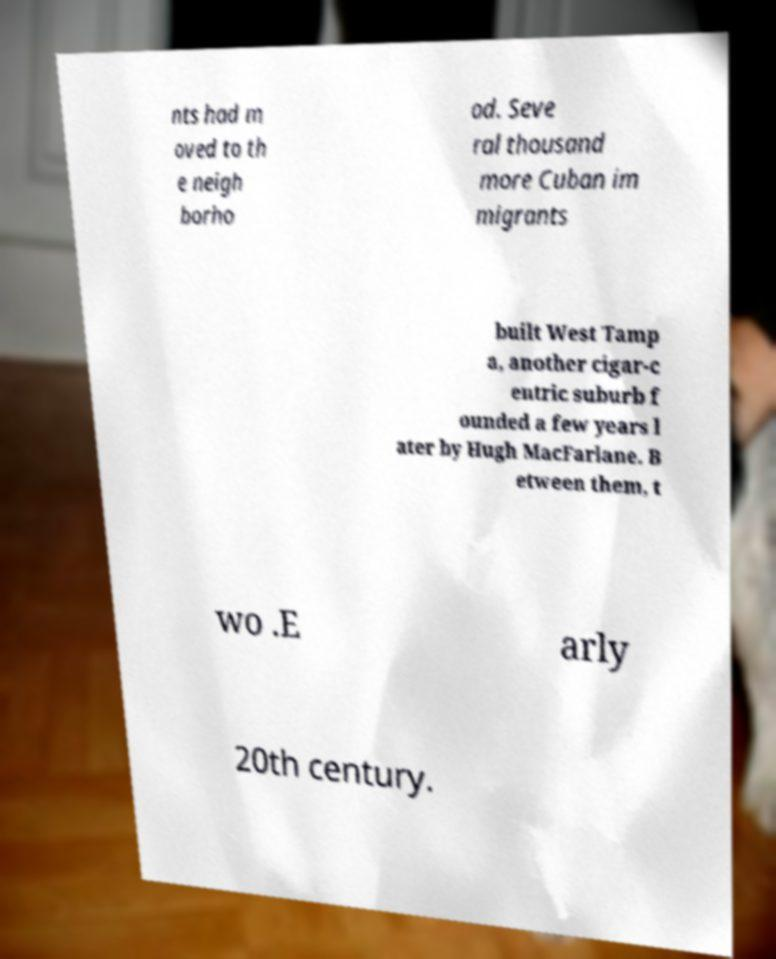Could you assist in decoding the text presented in this image and type it out clearly? nts had m oved to th e neigh borho od. Seve ral thousand more Cuban im migrants built West Tamp a, another cigar-c entric suburb f ounded a few years l ater by Hugh MacFarlane. B etween them, t wo .E arly 20th century. 